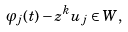<formula> <loc_0><loc_0><loc_500><loc_500>\varphi _ { j } ( t ) - z ^ { k } u _ { j } \in W ,</formula> 